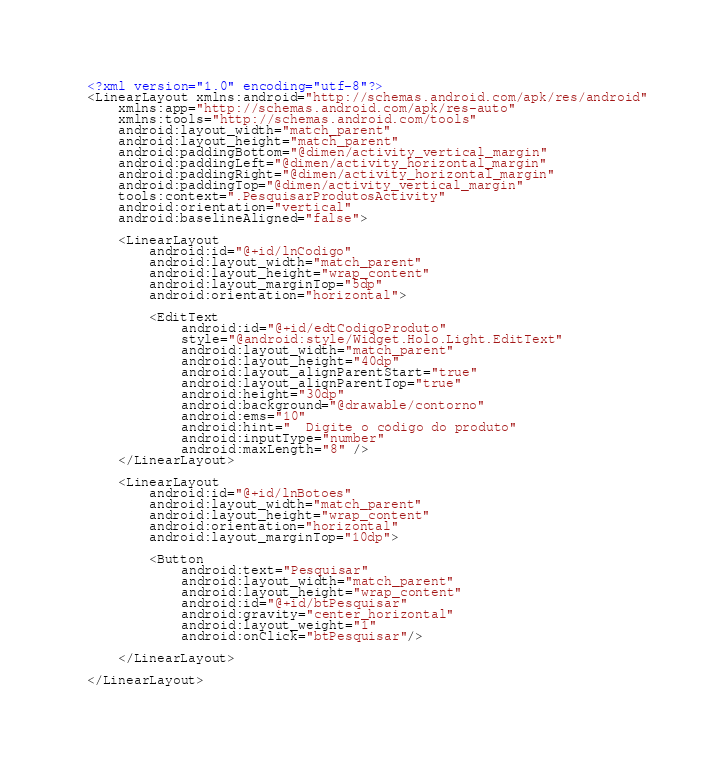<code> <loc_0><loc_0><loc_500><loc_500><_XML_><?xml version="1.0" encoding="utf-8"?>
<LinearLayout xmlns:android="http://schemas.android.com/apk/res/android"
    xmlns:app="http://schemas.android.com/apk/res-auto"
    xmlns:tools="http://schemas.android.com/tools"
    android:layout_width="match_parent"
    android:layout_height="match_parent"
    android:paddingBottom="@dimen/activity_vertical_margin"
    android:paddingLeft="@dimen/activity_horizontal_margin"
    android:paddingRight="@dimen/activity_horizontal_margin"
    android:paddingTop="@dimen/activity_vertical_margin"
    tools:context=".PesquisarProdutosActivity"
    android:orientation="vertical"
    android:baselineAligned="false">

    <LinearLayout
        android:id="@+id/lnCodigo"
        android:layout_width="match_parent"
        android:layout_height="wrap_content"
        android:layout_marginTop="5dp"
        android:orientation="horizontal">

        <EditText
            android:id="@+id/edtCodigoProduto"
            style="@android:style/Widget.Holo.Light.EditText"
            android:layout_width="match_parent"
            android:layout_height="40dp"
            android:layout_alignParentStart="true"
            android:layout_alignParentTop="true"
            android:height="30dp"
            android:background="@drawable/contorno"
            android:ems="10"
            android:hint="  Digite o código do produto"
            android:inputType="number"
            android:maxLength="8" />
    </LinearLayout>

    <LinearLayout
        android:id="@+id/lnBotoes"
        android:layout_width="match_parent"
        android:layout_height="wrap_content"
        android:orientation="horizontal"
        android:layout_marginTop="10dp">

        <Button
            android:text="Pesquisar"
            android:layout_width="match_parent"
            android:layout_height="wrap_content"
            android:id="@+id/btPesquisar"
            android:gravity="center_horizontal"
            android:layout_weight="1"
            android:onClick="btPesquisar"/>

    </LinearLayout>

</LinearLayout></code> 